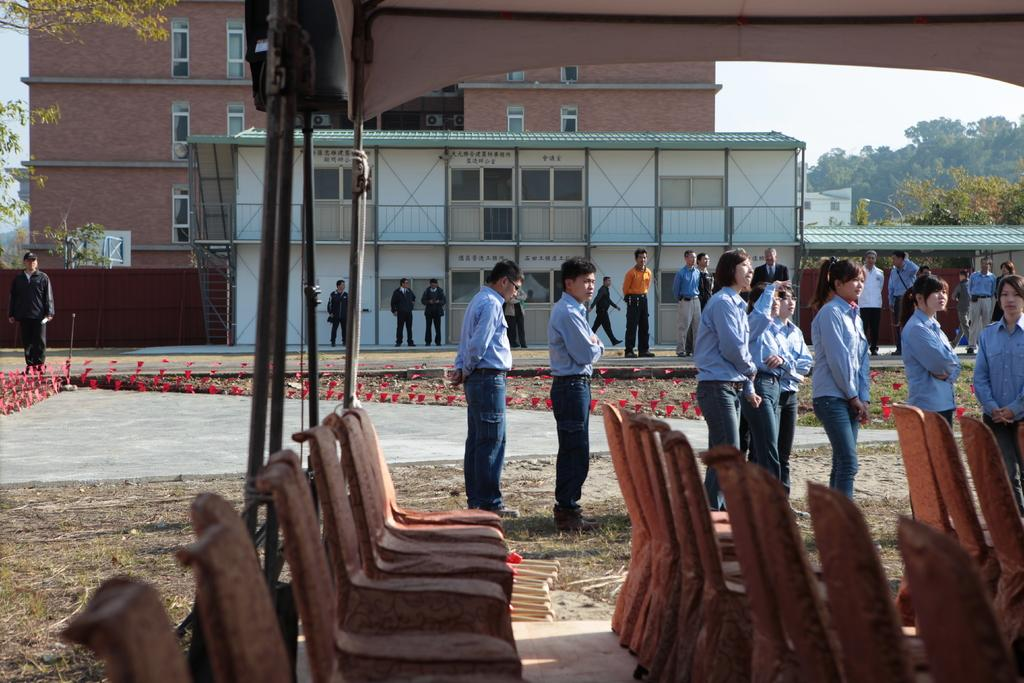What type of furniture is present in the image? There are chairs in the image. Can you describe the people in the image? There are people in the image. What can be seen in the background of the image? There is a building and trees in the background of the image. What type of food is being served on the trucks in the image? There are no trucks present in the image, so it is not possible to answer that question. 